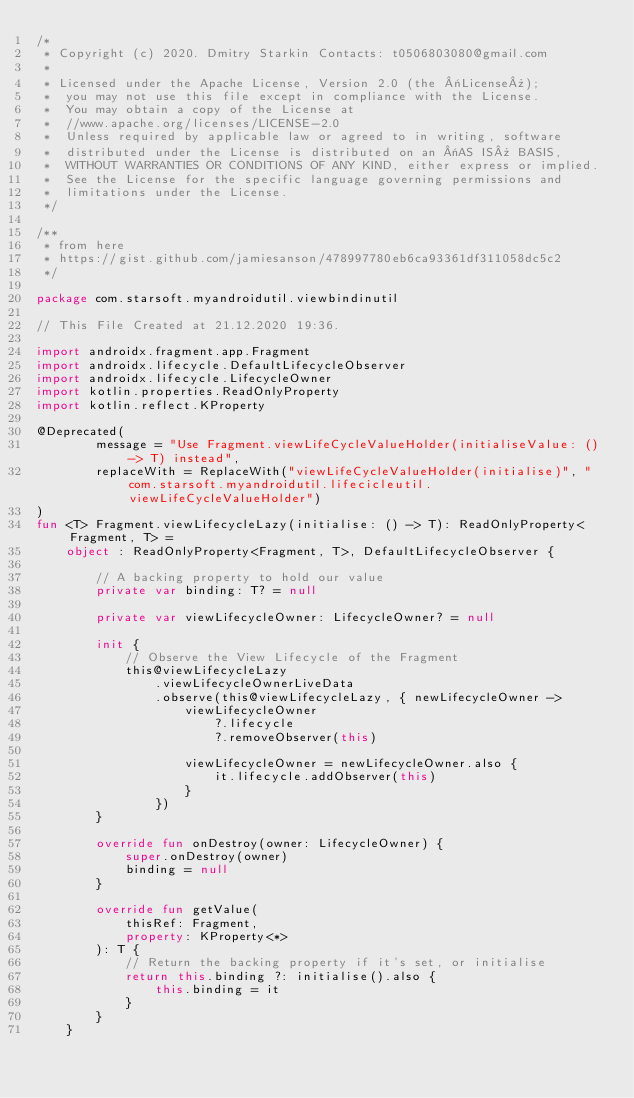Convert code to text. <code><loc_0><loc_0><loc_500><loc_500><_Kotlin_>/*
 * Copyright (c) 2020. Dmitry Starkin Contacts: t0506803080@gmail.com
 *
 * Licensed under the Apache License, Version 2.0 (the «License»);
 *  you may not use this file except in compliance with the License.
 *  You may obtain a copy of the License at
 *  //www.apache.org/licenses/LICENSE-2.0
 *  Unless required by applicable law or agreed to in writing, software
 *  distributed under the License is distributed on an «AS IS» BASIS,
 *  WITHOUT WARRANTIES OR CONDITIONS OF ANY KIND, either express or implied.
 *  See the License for the specific language governing permissions and
 *  limitations under the License.
 */

/**
 * from here
 * https://gist.github.com/jamiesanson/478997780eb6ca93361df311058dc5c2
 */

package com.starsoft.myandroidutil.viewbindinutil

// This File Created at 21.12.2020 19:36.

import androidx.fragment.app.Fragment
import androidx.lifecycle.DefaultLifecycleObserver
import androidx.lifecycle.LifecycleOwner
import kotlin.properties.ReadOnlyProperty
import kotlin.reflect.KProperty

@Deprecated(
        message = "Use Fragment.viewLifeCycleValueHolder(initialiseValue: () -> T) instead",
        replaceWith = ReplaceWith("viewLifeCycleValueHolder(initialise)", "com.starsoft.myandroidutil.lifecicleutil.viewLifeCycleValueHolder")
)
fun <T> Fragment.viewLifecycleLazy(initialise: () -> T): ReadOnlyProperty<Fragment, T> =
    object : ReadOnlyProperty<Fragment, T>, DefaultLifecycleObserver {

        // A backing property to hold our value
        private var binding: T? = null

        private var viewLifecycleOwner: LifecycleOwner? = null

        init {
            // Observe the View Lifecycle of the Fragment
            this@viewLifecycleLazy
                .viewLifecycleOwnerLiveData
                .observe(this@viewLifecycleLazy, { newLifecycleOwner ->
                    viewLifecycleOwner
                        ?.lifecycle
                        ?.removeObserver(this)

                    viewLifecycleOwner = newLifecycleOwner.also {
                        it.lifecycle.addObserver(this)
                    }
                })
        }

        override fun onDestroy(owner: LifecycleOwner) {
            super.onDestroy(owner)
            binding = null
        }

        override fun getValue(
            thisRef: Fragment,
            property: KProperty<*>
        ): T {
            // Return the backing property if it's set, or initialise
            return this.binding ?: initialise().also {
                this.binding = it
            }
        }
    }</code> 